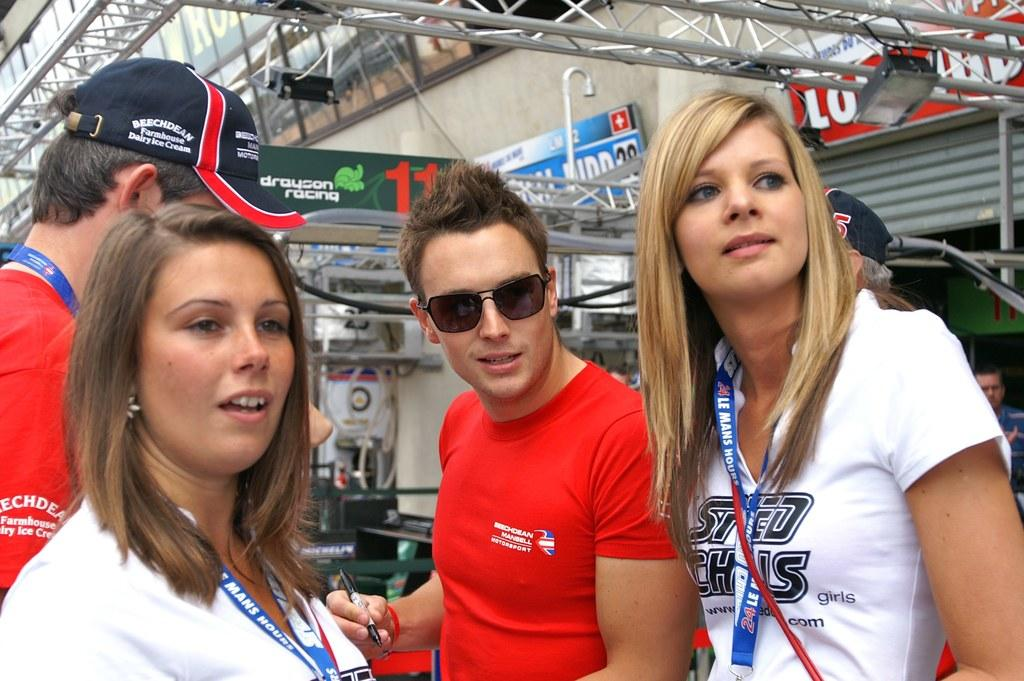What is the main subject of the image? The main subject of the image is a group of people. Where are the people located in the image? The group of people is in front of a building. What are the people wearing in the image? The people are wearing clothes. Can you describe the person in the middle of the image? The person in the middle is wearing sunglasses and holding a pen. What time of day is it in the image, and can you see any ghosts? The time of day is not mentioned in the image, and there are no ghosts present. What is the person in the middle of the image writing on their list? There is no list present in the image, so it cannot be determined what the person is writing. 